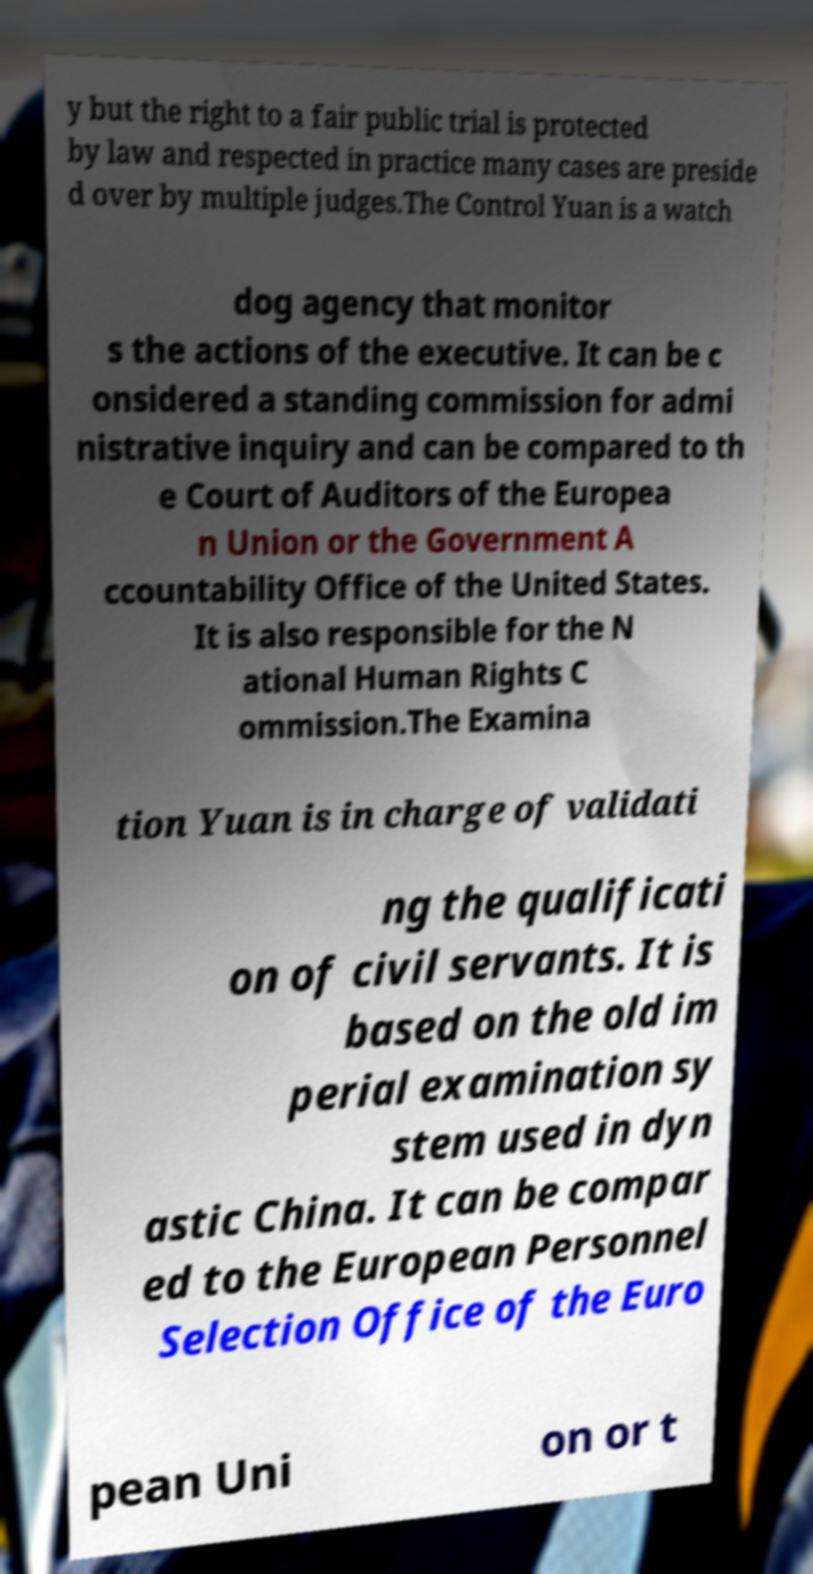Please read and relay the text visible in this image. What does it say? y but the right to a fair public trial is protected by law and respected in practice many cases are preside d over by multiple judges.The Control Yuan is a watch dog agency that monitor s the actions of the executive. It can be c onsidered a standing commission for admi nistrative inquiry and can be compared to th e Court of Auditors of the Europea n Union or the Government A ccountability Office of the United States. It is also responsible for the N ational Human Rights C ommission.The Examina tion Yuan is in charge of validati ng the qualificati on of civil servants. It is based on the old im perial examination sy stem used in dyn astic China. It can be compar ed to the European Personnel Selection Office of the Euro pean Uni on or t 